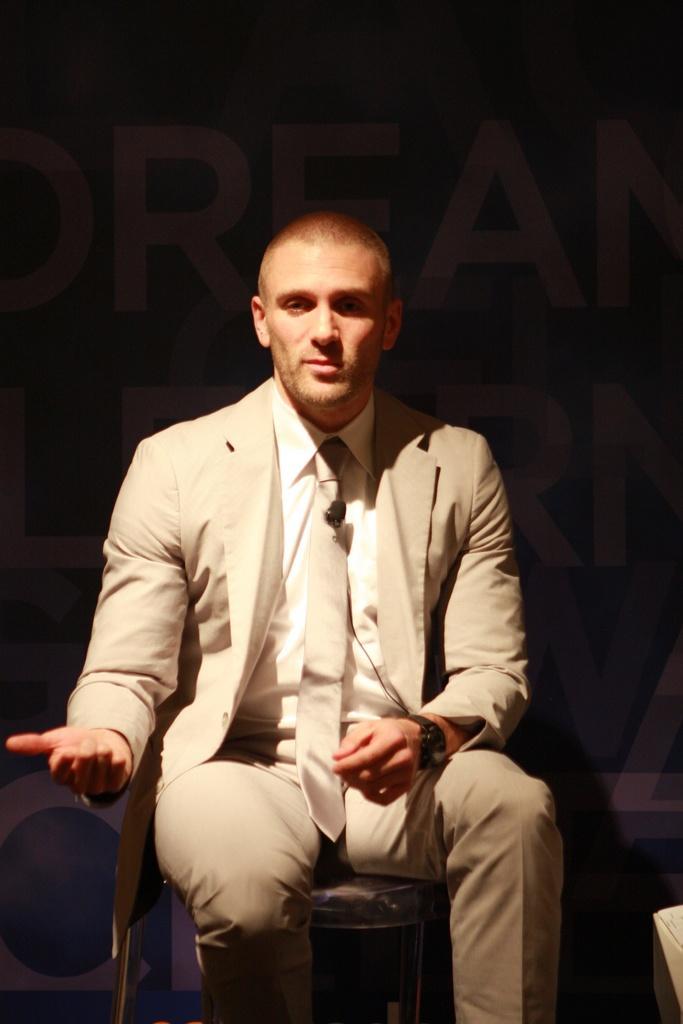Describe this image in one or two sentences. In this image there is a person sitting and he is wearing suit in the foreground. There is text and the background is dark. 